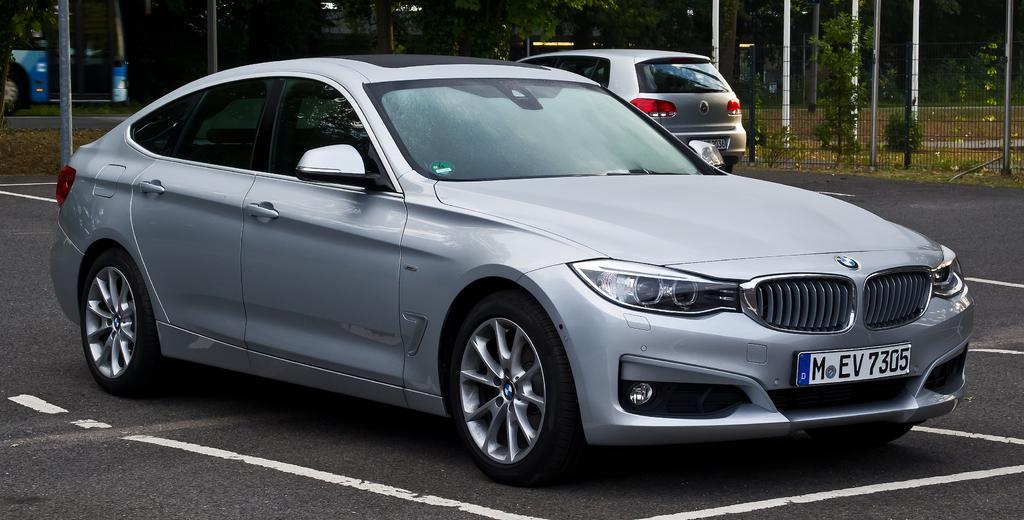Please provide a concise description of this image. In this image, we can see vehicles on the road and in the background, there are trees, poles and we can see a fence and some plants. 